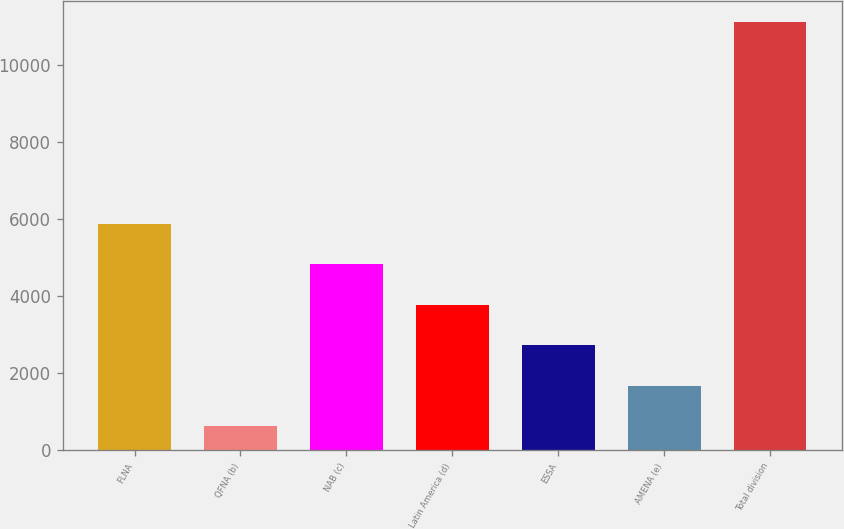Convert chart to OTSL. <chart><loc_0><loc_0><loc_500><loc_500><bar_chart><fcel>FLNA<fcel>QFNA (b)<fcel>NAB (c)<fcel>Latin America (d)<fcel>ESSA<fcel>AMENA (e)<fcel>Total division<nl><fcel>5863.5<fcel>621<fcel>4815<fcel>3766.5<fcel>2718<fcel>1669.5<fcel>11106<nl></chart> 